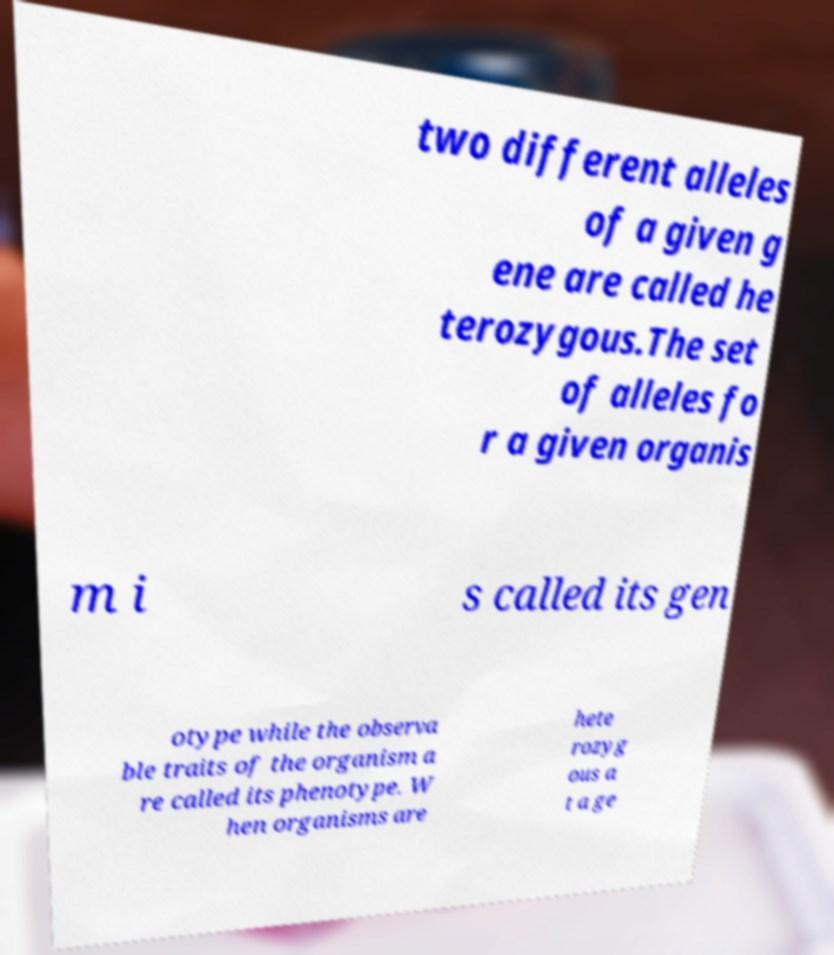Could you assist in decoding the text presented in this image and type it out clearly? two different alleles of a given g ene are called he terozygous.The set of alleles fo r a given organis m i s called its gen otype while the observa ble traits of the organism a re called its phenotype. W hen organisms are hete rozyg ous a t a ge 